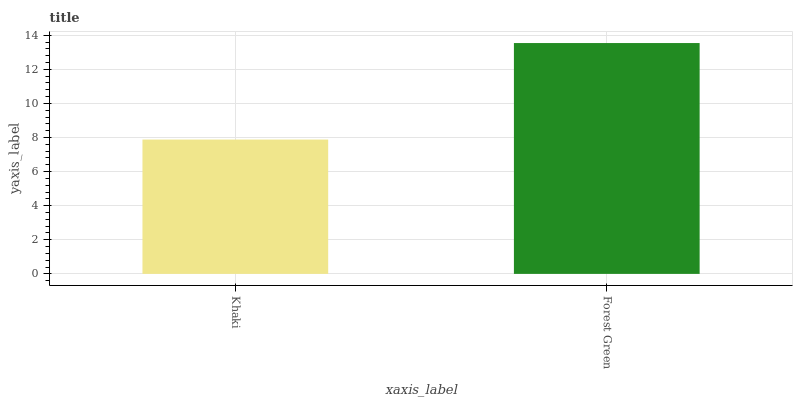Is Khaki the minimum?
Answer yes or no. Yes. Is Forest Green the maximum?
Answer yes or no. Yes. Is Forest Green the minimum?
Answer yes or no. No. Is Forest Green greater than Khaki?
Answer yes or no. Yes. Is Khaki less than Forest Green?
Answer yes or no. Yes. Is Khaki greater than Forest Green?
Answer yes or no. No. Is Forest Green less than Khaki?
Answer yes or no. No. Is Forest Green the high median?
Answer yes or no. Yes. Is Khaki the low median?
Answer yes or no. Yes. Is Khaki the high median?
Answer yes or no. No. Is Forest Green the low median?
Answer yes or no. No. 